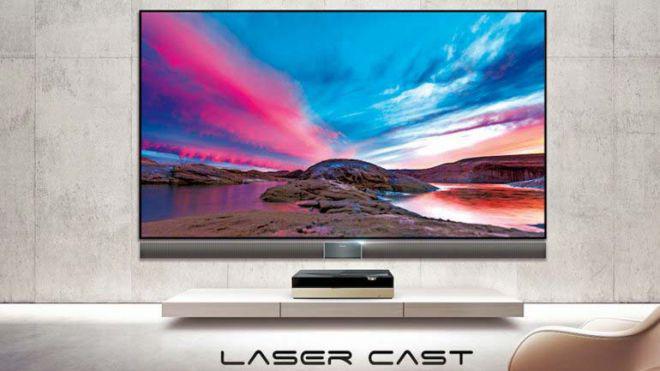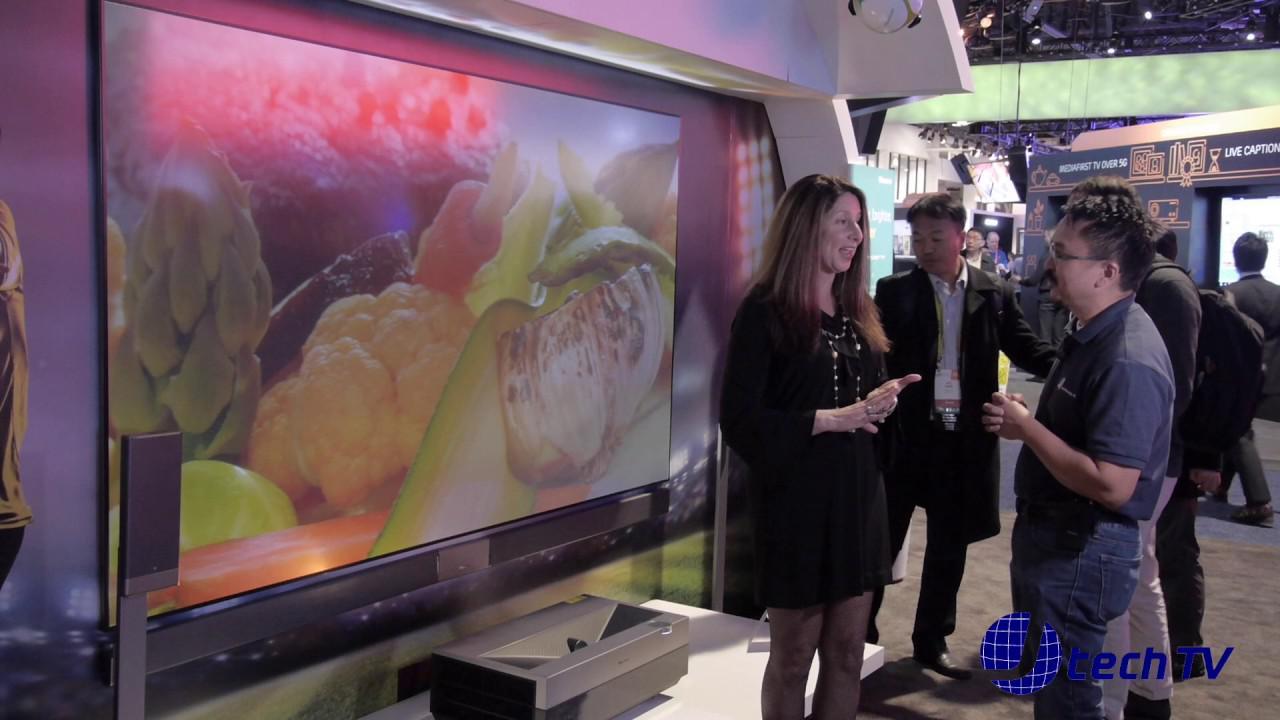The first image is the image on the left, the second image is the image on the right. Given the left and right images, does the statement "In at least one image you can see a green background and a hummingbird on the tv that is below gold lettering." hold true? Answer yes or no. No. The first image is the image on the left, the second image is the image on the right. Considering the images on both sides, is "One of the television sets is showing a pink flower on a green background." valid? Answer yes or no. No. 